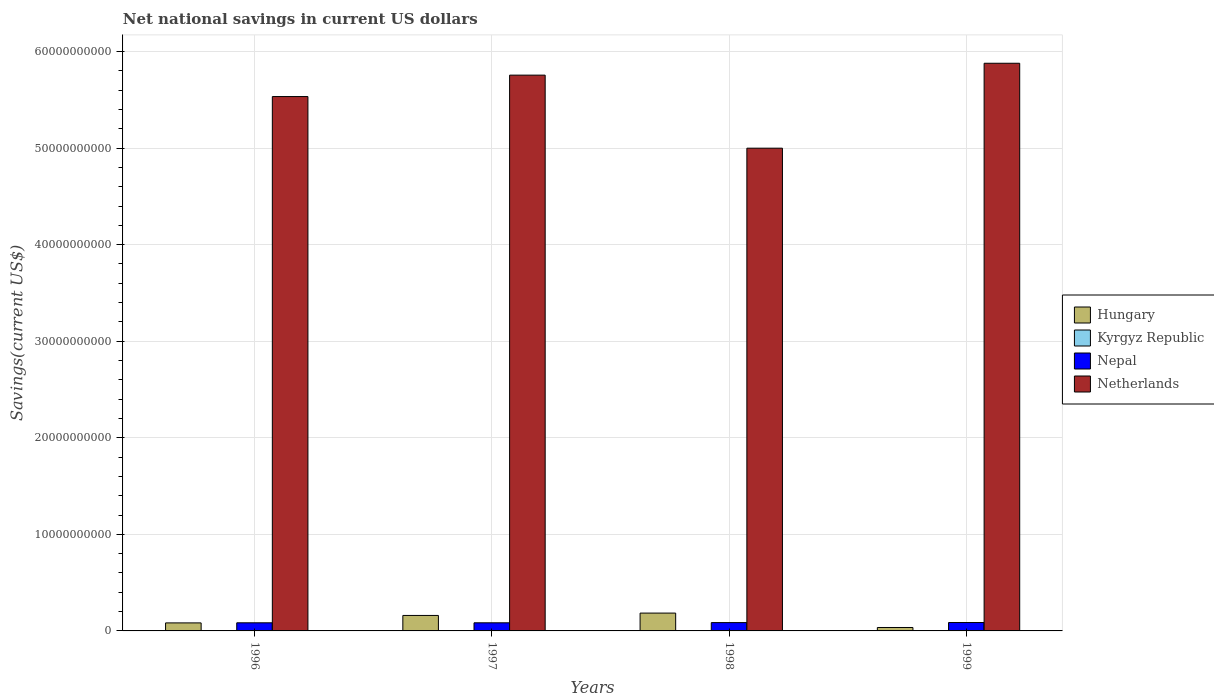How many different coloured bars are there?
Your answer should be compact. 4. Are the number of bars per tick equal to the number of legend labels?
Give a very brief answer. No. What is the net national savings in Nepal in 1997?
Your response must be concise. 8.41e+08. Across all years, what is the maximum net national savings in Nepal?
Ensure brevity in your answer.  8.70e+08. Across all years, what is the minimum net national savings in Netherlands?
Make the answer very short. 5.00e+1. In which year was the net national savings in Hungary maximum?
Your answer should be very brief. 1998. What is the total net national savings in Kyrgyz Republic in the graph?
Provide a succinct answer. 3.15e+07. What is the difference between the net national savings in Nepal in 1996 and that in 1999?
Your answer should be compact. -2.97e+07. What is the difference between the net national savings in Kyrgyz Republic in 1996 and the net national savings in Hungary in 1999?
Your response must be concise. -3.55e+08. What is the average net national savings in Nepal per year?
Give a very brief answer. 8.53e+08. In the year 1997, what is the difference between the net national savings in Nepal and net national savings in Hungary?
Offer a very short reply. -7.62e+08. In how many years, is the net national savings in Kyrgyz Republic greater than 32000000000 US$?
Give a very brief answer. 0. What is the ratio of the net national savings in Nepal in 1997 to that in 1999?
Keep it short and to the point. 0.97. Is the difference between the net national savings in Nepal in 1997 and 1999 greater than the difference between the net national savings in Hungary in 1997 and 1999?
Provide a short and direct response. No. What is the difference between the highest and the second highest net national savings in Nepal?
Provide a short and direct response. 8.51e+06. What is the difference between the highest and the lowest net national savings in Hungary?
Offer a terse response. 1.49e+09. Is the sum of the net national savings in Nepal in 1996 and 1999 greater than the maximum net national savings in Hungary across all years?
Give a very brief answer. No. How many bars are there?
Give a very brief answer. 13. How many years are there in the graph?
Your answer should be compact. 4. What is the difference between two consecutive major ticks on the Y-axis?
Keep it short and to the point. 1.00e+1. What is the title of the graph?
Provide a short and direct response. Net national savings in current US dollars. Does "Iceland" appear as one of the legend labels in the graph?
Keep it short and to the point. No. What is the label or title of the X-axis?
Keep it short and to the point. Years. What is the label or title of the Y-axis?
Your response must be concise. Savings(current US$). What is the Savings(current US$) of Hungary in 1996?
Keep it short and to the point. 8.30e+08. What is the Savings(current US$) in Kyrgyz Republic in 1996?
Give a very brief answer. 0. What is the Savings(current US$) of Nepal in 1996?
Keep it short and to the point. 8.41e+08. What is the Savings(current US$) of Netherlands in 1996?
Your answer should be compact. 5.53e+1. What is the Savings(current US$) in Hungary in 1997?
Offer a terse response. 1.60e+09. What is the Savings(current US$) of Kyrgyz Republic in 1997?
Your answer should be very brief. 3.15e+07. What is the Savings(current US$) of Nepal in 1997?
Your response must be concise. 8.41e+08. What is the Savings(current US$) in Netherlands in 1997?
Your answer should be compact. 5.76e+1. What is the Savings(current US$) in Hungary in 1998?
Your response must be concise. 1.85e+09. What is the Savings(current US$) of Nepal in 1998?
Provide a succinct answer. 8.62e+08. What is the Savings(current US$) of Netherlands in 1998?
Offer a very short reply. 5.00e+1. What is the Savings(current US$) of Hungary in 1999?
Offer a very short reply. 3.55e+08. What is the Savings(current US$) in Kyrgyz Republic in 1999?
Ensure brevity in your answer.  0. What is the Savings(current US$) in Nepal in 1999?
Your answer should be very brief. 8.70e+08. What is the Savings(current US$) in Netherlands in 1999?
Ensure brevity in your answer.  5.88e+1. Across all years, what is the maximum Savings(current US$) in Hungary?
Offer a terse response. 1.85e+09. Across all years, what is the maximum Savings(current US$) in Kyrgyz Republic?
Your answer should be compact. 3.15e+07. Across all years, what is the maximum Savings(current US$) of Nepal?
Ensure brevity in your answer.  8.70e+08. Across all years, what is the maximum Savings(current US$) of Netherlands?
Make the answer very short. 5.88e+1. Across all years, what is the minimum Savings(current US$) of Hungary?
Keep it short and to the point. 3.55e+08. Across all years, what is the minimum Savings(current US$) of Nepal?
Your answer should be very brief. 8.41e+08. Across all years, what is the minimum Savings(current US$) in Netherlands?
Give a very brief answer. 5.00e+1. What is the total Savings(current US$) of Hungary in the graph?
Keep it short and to the point. 4.63e+09. What is the total Savings(current US$) in Kyrgyz Republic in the graph?
Provide a succinct answer. 3.15e+07. What is the total Savings(current US$) in Nepal in the graph?
Ensure brevity in your answer.  3.41e+09. What is the total Savings(current US$) of Netherlands in the graph?
Your response must be concise. 2.22e+11. What is the difference between the Savings(current US$) of Hungary in 1996 and that in 1997?
Keep it short and to the point. -7.72e+08. What is the difference between the Savings(current US$) of Nepal in 1996 and that in 1997?
Give a very brief answer. -9.16e+04. What is the difference between the Savings(current US$) of Netherlands in 1996 and that in 1997?
Offer a terse response. -2.22e+09. What is the difference between the Savings(current US$) in Hungary in 1996 and that in 1998?
Your response must be concise. -1.02e+09. What is the difference between the Savings(current US$) of Nepal in 1996 and that in 1998?
Make the answer very short. -2.11e+07. What is the difference between the Savings(current US$) of Netherlands in 1996 and that in 1998?
Keep it short and to the point. 5.35e+09. What is the difference between the Savings(current US$) in Hungary in 1996 and that in 1999?
Your answer should be very brief. 4.75e+08. What is the difference between the Savings(current US$) in Nepal in 1996 and that in 1999?
Provide a succinct answer. -2.97e+07. What is the difference between the Savings(current US$) of Netherlands in 1996 and that in 1999?
Give a very brief answer. -3.45e+09. What is the difference between the Savings(current US$) of Hungary in 1997 and that in 1998?
Give a very brief answer. -2.44e+08. What is the difference between the Savings(current US$) of Nepal in 1997 and that in 1998?
Your answer should be compact. -2.10e+07. What is the difference between the Savings(current US$) of Netherlands in 1997 and that in 1998?
Ensure brevity in your answer.  7.56e+09. What is the difference between the Savings(current US$) in Hungary in 1997 and that in 1999?
Provide a succinct answer. 1.25e+09. What is the difference between the Savings(current US$) of Nepal in 1997 and that in 1999?
Your response must be concise. -2.96e+07. What is the difference between the Savings(current US$) of Netherlands in 1997 and that in 1999?
Your answer should be very brief. -1.23e+09. What is the difference between the Savings(current US$) in Hungary in 1998 and that in 1999?
Make the answer very short. 1.49e+09. What is the difference between the Savings(current US$) of Nepal in 1998 and that in 1999?
Ensure brevity in your answer.  -8.51e+06. What is the difference between the Savings(current US$) of Netherlands in 1998 and that in 1999?
Ensure brevity in your answer.  -8.79e+09. What is the difference between the Savings(current US$) in Hungary in 1996 and the Savings(current US$) in Kyrgyz Republic in 1997?
Offer a terse response. 7.99e+08. What is the difference between the Savings(current US$) of Hungary in 1996 and the Savings(current US$) of Nepal in 1997?
Provide a short and direct response. -1.05e+07. What is the difference between the Savings(current US$) in Hungary in 1996 and the Savings(current US$) in Netherlands in 1997?
Provide a succinct answer. -5.67e+1. What is the difference between the Savings(current US$) in Nepal in 1996 and the Savings(current US$) in Netherlands in 1997?
Your answer should be very brief. -5.67e+1. What is the difference between the Savings(current US$) in Hungary in 1996 and the Savings(current US$) in Nepal in 1998?
Offer a terse response. -3.16e+07. What is the difference between the Savings(current US$) of Hungary in 1996 and the Savings(current US$) of Netherlands in 1998?
Provide a succinct answer. -4.92e+1. What is the difference between the Savings(current US$) in Nepal in 1996 and the Savings(current US$) in Netherlands in 1998?
Make the answer very short. -4.92e+1. What is the difference between the Savings(current US$) in Hungary in 1996 and the Savings(current US$) in Nepal in 1999?
Your answer should be very brief. -4.01e+07. What is the difference between the Savings(current US$) of Hungary in 1996 and the Savings(current US$) of Netherlands in 1999?
Keep it short and to the point. -5.80e+1. What is the difference between the Savings(current US$) in Nepal in 1996 and the Savings(current US$) in Netherlands in 1999?
Ensure brevity in your answer.  -5.79e+1. What is the difference between the Savings(current US$) in Hungary in 1997 and the Savings(current US$) in Nepal in 1998?
Make the answer very short. 7.41e+08. What is the difference between the Savings(current US$) of Hungary in 1997 and the Savings(current US$) of Netherlands in 1998?
Ensure brevity in your answer.  -4.84e+1. What is the difference between the Savings(current US$) of Kyrgyz Republic in 1997 and the Savings(current US$) of Nepal in 1998?
Provide a short and direct response. -8.30e+08. What is the difference between the Savings(current US$) in Kyrgyz Republic in 1997 and the Savings(current US$) in Netherlands in 1998?
Provide a short and direct response. -5.00e+1. What is the difference between the Savings(current US$) in Nepal in 1997 and the Savings(current US$) in Netherlands in 1998?
Make the answer very short. -4.92e+1. What is the difference between the Savings(current US$) in Hungary in 1997 and the Savings(current US$) in Nepal in 1999?
Give a very brief answer. 7.32e+08. What is the difference between the Savings(current US$) in Hungary in 1997 and the Savings(current US$) in Netherlands in 1999?
Your response must be concise. -5.72e+1. What is the difference between the Savings(current US$) in Kyrgyz Republic in 1997 and the Savings(current US$) in Nepal in 1999?
Your answer should be compact. -8.39e+08. What is the difference between the Savings(current US$) in Kyrgyz Republic in 1997 and the Savings(current US$) in Netherlands in 1999?
Offer a very short reply. -5.88e+1. What is the difference between the Savings(current US$) in Nepal in 1997 and the Savings(current US$) in Netherlands in 1999?
Your response must be concise. -5.79e+1. What is the difference between the Savings(current US$) of Hungary in 1998 and the Savings(current US$) of Nepal in 1999?
Provide a short and direct response. 9.76e+08. What is the difference between the Savings(current US$) of Hungary in 1998 and the Savings(current US$) of Netherlands in 1999?
Provide a succinct answer. -5.69e+1. What is the difference between the Savings(current US$) in Nepal in 1998 and the Savings(current US$) in Netherlands in 1999?
Keep it short and to the point. -5.79e+1. What is the average Savings(current US$) of Hungary per year?
Make the answer very short. 1.16e+09. What is the average Savings(current US$) in Kyrgyz Republic per year?
Offer a very short reply. 7.89e+06. What is the average Savings(current US$) of Nepal per year?
Make the answer very short. 8.53e+08. What is the average Savings(current US$) in Netherlands per year?
Offer a terse response. 5.54e+1. In the year 1996, what is the difference between the Savings(current US$) in Hungary and Savings(current US$) in Nepal?
Give a very brief answer. -1.04e+07. In the year 1996, what is the difference between the Savings(current US$) in Hungary and Savings(current US$) in Netherlands?
Give a very brief answer. -5.45e+1. In the year 1996, what is the difference between the Savings(current US$) in Nepal and Savings(current US$) in Netherlands?
Give a very brief answer. -5.45e+1. In the year 1997, what is the difference between the Savings(current US$) in Hungary and Savings(current US$) in Kyrgyz Republic?
Your response must be concise. 1.57e+09. In the year 1997, what is the difference between the Savings(current US$) of Hungary and Savings(current US$) of Nepal?
Provide a succinct answer. 7.62e+08. In the year 1997, what is the difference between the Savings(current US$) of Hungary and Savings(current US$) of Netherlands?
Offer a very short reply. -5.60e+1. In the year 1997, what is the difference between the Savings(current US$) of Kyrgyz Republic and Savings(current US$) of Nepal?
Offer a terse response. -8.09e+08. In the year 1997, what is the difference between the Savings(current US$) in Kyrgyz Republic and Savings(current US$) in Netherlands?
Keep it short and to the point. -5.75e+1. In the year 1997, what is the difference between the Savings(current US$) in Nepal and Savings(current US$) in Netherlands?
Offer a very short reply. -5.67e+1. In the year 1998, what is the difference between the Savings(current US$) in Hungary and Savings(current US$) in Nepal?
Keep it short and to the point. 9.85e+08. In the year 1998, what is the difference between the Savings(current US$) in Hungary and Savings(current US$) in Netherlands?
Your response must be concise. -4.81e+1. In the year 1998, what is the difference between the Savings(current US$) of Nepal and Savings(current US$) of Netherlands?
Give a very brief answer. -4.91e+1. In the year 1999, what is the difference between the Savings(current US$) in Hungary and Savings(current US$) in Nepal?
Make the answer very short. -5.16e+08. In the year 1999, what is the difference between the Savings(current US$) of Hungary and Savings(current US$) of Netherlands?
Your answer should be very brief. -5.84e+1. In the year 1999, what is the difference between the Savings(current US$) of Nepal and Savings(current US$) of Netherlands?
Your answer should be compact. -5.79e+1. What is the ratio of the Savings(current US$) of Hungary in 1996 to that in 1997?
Your response must be concise. 0.52. What is the ratio of the Savings(current US$) of Netherlands in 1996 to that in 1997?
Make the answer very short. 0.96. What is the ratio of the Savings(current US$) in Hungary in 1996 to that in 1998?
Offer a very short reply. 0.45. What is the ratio of the Savings(current US$) in Nepal in 1996 to that in 1998?
Your answer should be very brief. 0.98. What is the ratio of the Savings(current US$) of Netherlands in 1996 to that in 1998?
Make the answer very short. 1.11. What is the ratio of the Savings(current US$) of Hungary in 1996 to that in 1999?
Offer a terse response. 2.34. What is the ratio of the Savings(current US$) in Nepal in 1996 to that in 1999?
Ensure brevity in your answer.  0.97. What is the ratio of the Savings(current US$) in Netherlands in 1996 to that in 1999?
Offer a terse response. 0.94. What is the ratio of the Savings(current US$) of Hungary in 1997 to that in 1998?
Your answer should be compact. 0.87. What is the ratio of the Savings(current US$) in Nepal in 1997 to that in 1998?
Your answer should be very brief. 0.98. What is the ratio of the Savings(current US$) in Netherlands in 1997 to that in 1998?
Your answer should be very brief. 1.15. What is the ratio of the Savings(current US$) of Hungary in 1997 to that in 1999?
Provide a short and direct response. 4.52. What is the ratio of the Savings(current US$) of Netherlands in 1997 to that in 1999?
Your answer should be very brief. 0.98. What is the ratio of the Savings(current US$) of Hungary in 1998 to that in 1999?
Give a very brief answer. 5.21. What is the ratio of the Savings(current US$) of Nepal in 1998 to that in 1999?
Your answer should be very brief. 0.99. What is the ratio of the Savings(current US$) of Netherlands in 1998 to that in 1999?
Provide a succinct answer. 0.85. What is the difference between the highest and the second highest Savings(current US$) in Hungary?
Your response must be concise. 2.44e+08. What is the difference between the highest and the second highest Savings(current US$) of Nepal?
Give a very brief answer. 8.51e+06. What is the difference between the highest and the second highest Savings(current US$) of Netherlands?
Keep it short and to the point. 1.23e+09. What is the difference between the highest and the lowest Savings(current US$) of Hungary?
Ensure brevity in your answer.  1.49e+09. What is the difference between the highest and the lowest Savings(current US$) of Kyrgyz Republic?
Keep it short and to the point. 3.15e+07. What is the difference between the highest and the lowest Savings(current US$) in Nepal?
Your answer should be very brief. 2.97e+07. What is the difference between the highest and the lowest Savings(current US$) in Netherlands?
Provide a succinct answer. 8.79e+09. 